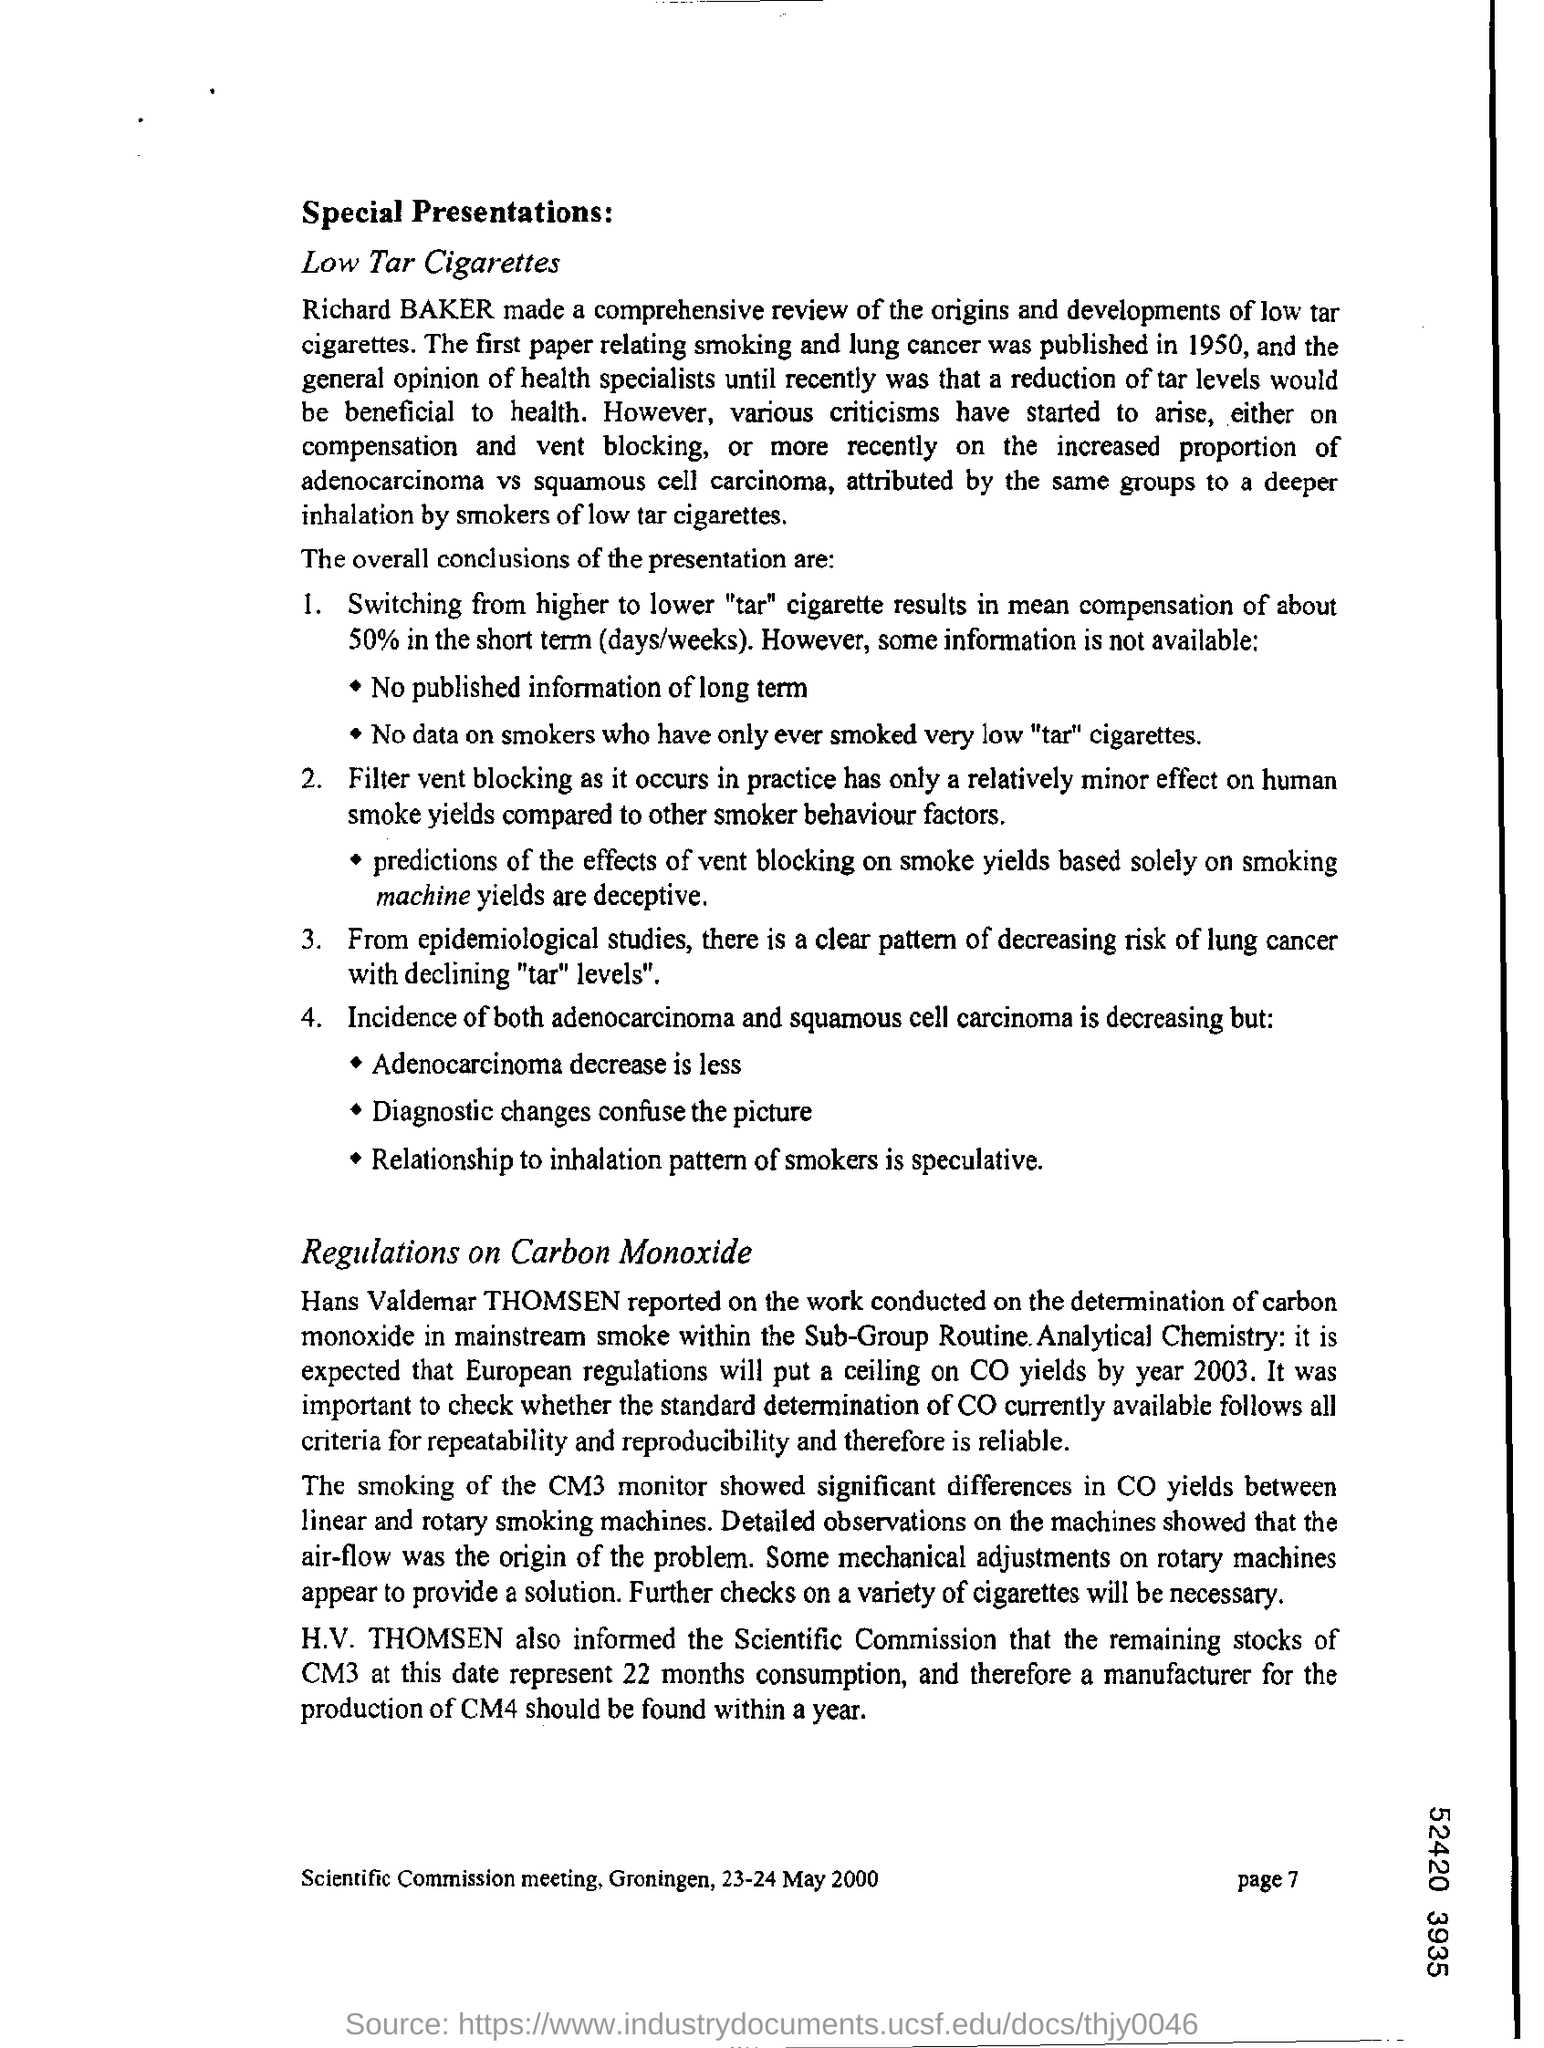Mention the page number at bottom right corner of the page ?
Ensure brevity in your answer.  7. Who made a comprehensive review of the origins and developments of low tar cigarettes ?
Provide a succinct answer. Richard Baker. 